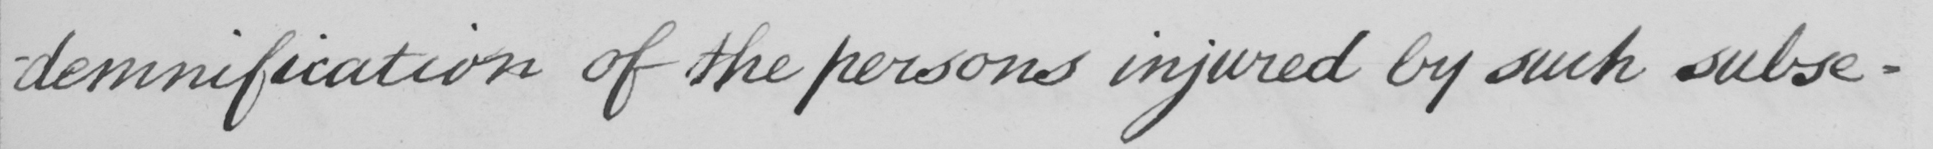Can you tell me what this handwritten text says? -demnification of the persons injured by such subse- 